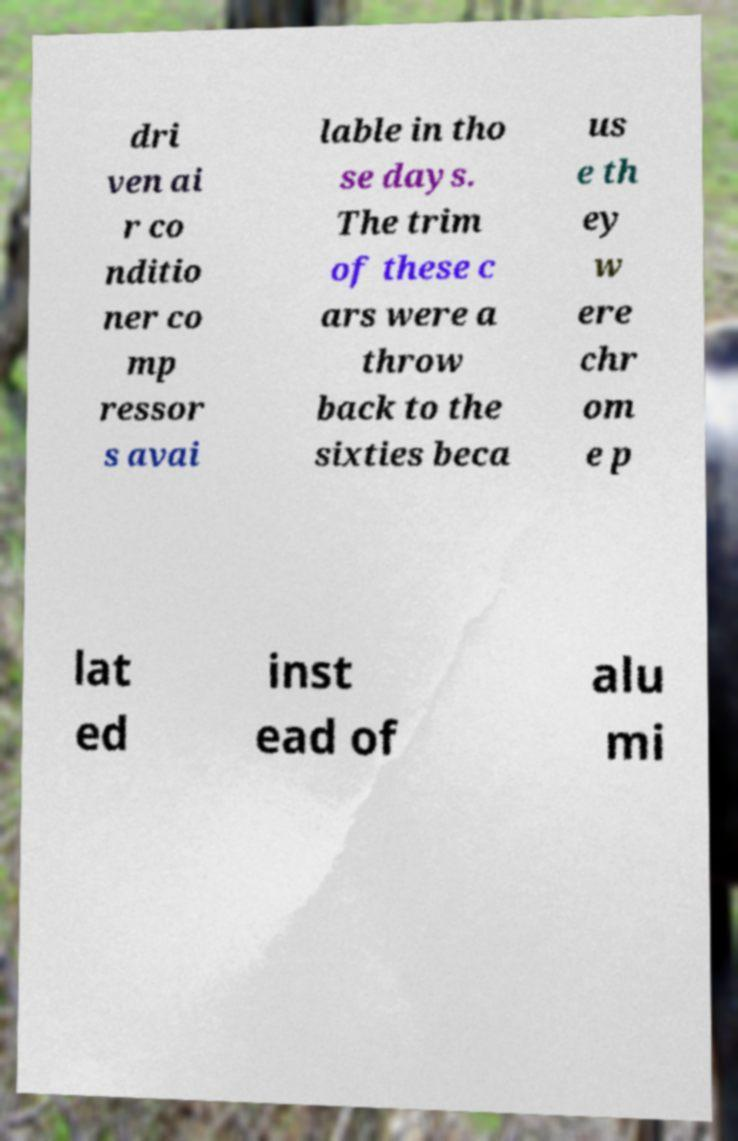Could you assist in decoding the text presented in this image and type it out clearly? dri ven ai r co nditio ner co mp ressor s avai lable in tho se days. The trim of these c ars were a throw back to the sixties beca us e th ey w ere chr om e p lat ed inst ead of alu mi 